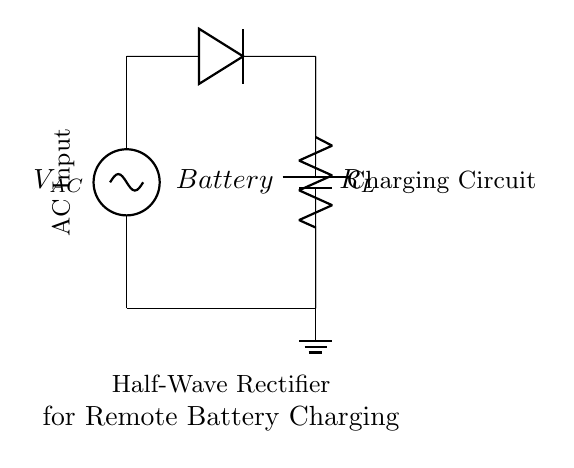What is the main function of the diode in this circuit? The diode allows current to flow in one direction only, blocking reverse current and thus converting AC to DC.
Answer: Allowing current in one direction What does the resistor represent in the circuit? The resistor represents the load connected to the circuit, which the current will flow through after rectification.
Answer: Load Which component is acting as the energy storage unit in this circuit? The battery is the energy storage unit, providing power after being charged by the rectified output.
Answer: Battery What type of rectification is being used in this circuit? The circuit uses half-wave rectification, indicated by the diode allowing only one half of the AC waveform to charge the battery.
Answer: Half-wave rectification How many diodes are present in the circuit? There is one diode in the circuit, which is used to achieve the rectification process.
Answer: One What happens to the current when the AC input goes negative? When the AC input goes negative, the diode becomes reverse-biased and blocks the current, preventing it from flowing to the battery.
Answer: Current is blocked What is the role of the AC source in this circuit? The AC source provides the alternating current needed to be converted into direct current for charging the battery.
Answer: Power supply 